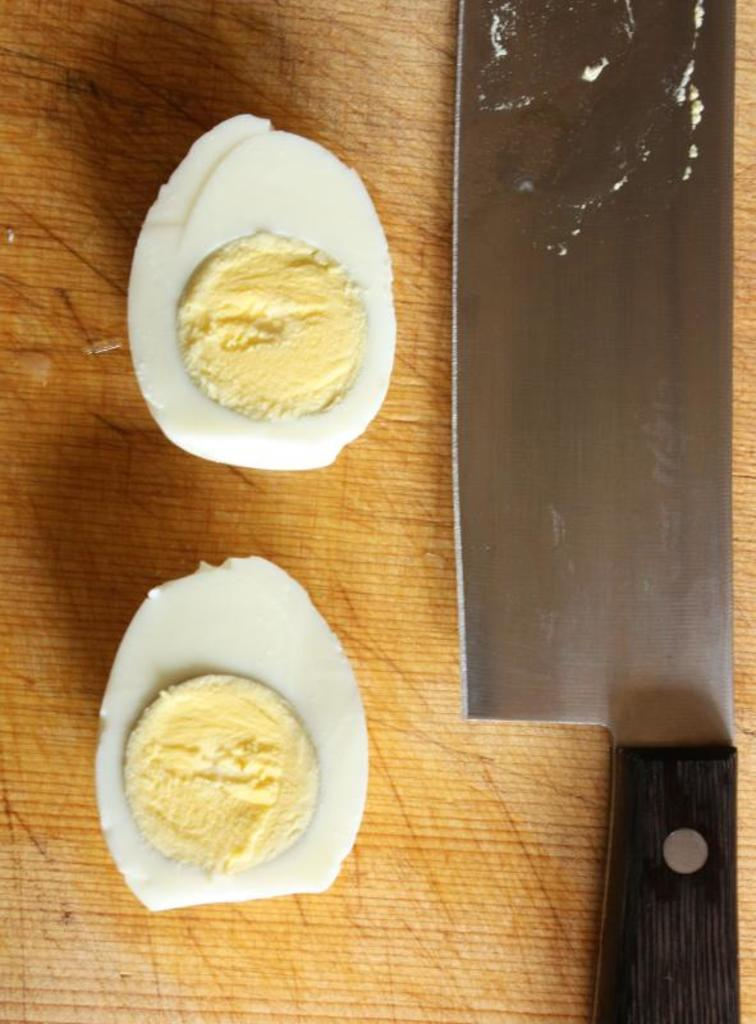What type of food can be seen in the image? There are boiled egg slices in the image. What utensil is present in the image? There is a knife in the image. What material is the surface on which the food and utensil are placed? The wooden surface is present in the image. What type of songs can be heard playing in the background of the image? There is no audio or music present in the image, so it is not possible to determine what songs might be heard. 